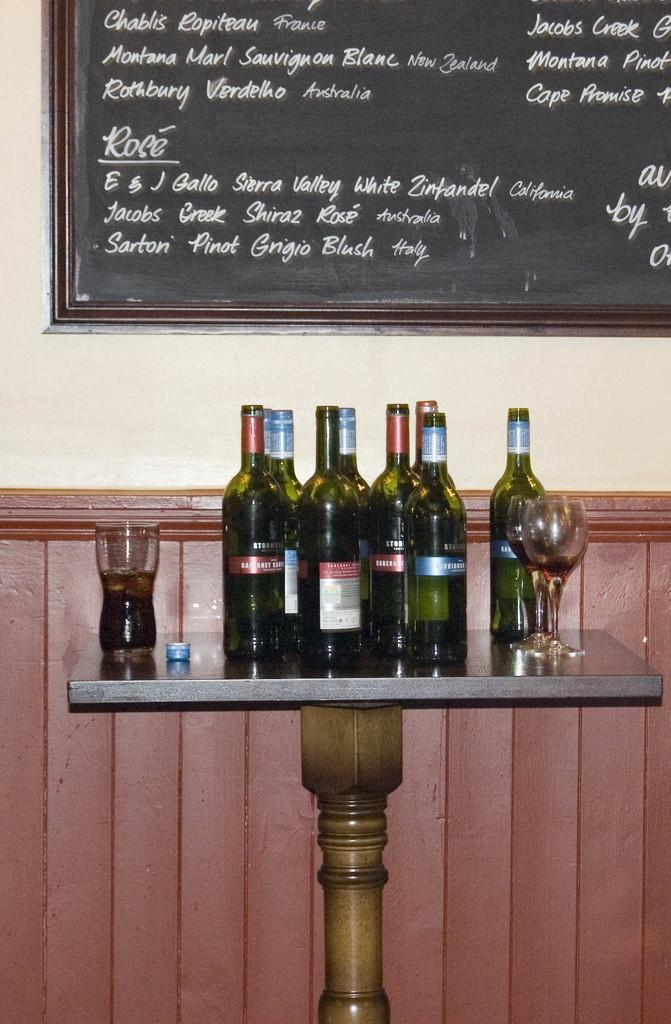<image>
Summarize the visual content of the image. Wine bottles on a table in front of menu that includes Chablis and Pinot Grigio. 